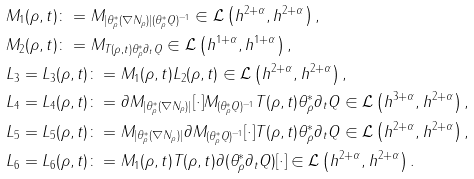Convert formula to latex. <formula><loc_0><loc_0><loc_500><loc_500>& M _ { 1 } ( \rho , t ) \colon = M _ { | \theta _ { \rho } ^ { \ast } ( \nabla N _ { \rho } ) | ( \theta _ { \rho } ^ { \ast } Q ) ^ { - 1 } } \in \mathcal { L } \left ( h ^ { 2 + \alpha } , h ^ { 2 + \alpha } \right ) , \\ & M _ { 2 } ( \rho , t ) \colon = M _ { T ( \rho , t ) \theta _ { \rho } ^ { \ast } \partial _ { t } Q } \in \mathcal { L } \left ( h ^ { 1 + \alpha } , h ^ { 1 + \alpha } \right ) , \\ & L _ { 3 } = L _ { 3 } ( \rho , t ) \colon = M _ { 1 } ( \rho , t ) L _ { 2 } ( \rho , t ) \in \mathcal { L } \left ( h ^ { 2 + \alpha } , h ^ { 2 + \alpha } \right ) , \\ & L _ { 4 } = L _ { 4 } ( \rho , t ) \colon = \partial M _ { | \theta _ { \rho } ^ { \ast } ( \nabla N _ { \rho } ) | } [ \cdot ] M _ { ( \theta _ { \rho } ^ { \ast } Q ) ^ { - 1 } } T ( \rho , t ) \theta _ { \rho } ^ { \ast } \partial _ { t } Q \in \mathcal { L } \left ( h ^ { 3 + \alpha } , h ^ { 2 + \alpha } \right ) , \\ & L _ { 5 } = L _ { 5 } ( \rho , t ) \colon = M _ { | \theta _ { \rho } ^ { \ast } ( \nabla N _ { \rho } ) | } \partial M _ { ( \theta _ { \rho } ^ { \ast } Q ) ^ { - 1 } } [ \cdot ] T ( \rho , t ) \theta _ { \rho } ^ { \ast } \partial _ { t } Q \in \mathcal { L } \left ( h ^ { 2 + \alpha } , h ^ { 2 + \alpha } \right ) , \\ & L _ { 6 } = L _ { 6 } ( \rho , t ) \colon = M _ { 1 } ( \rho , t ) T ( \rho , t ) \partial ( \theta _ { \rho } ^ { \ast } \partial _ { t } Q ) [ \cdot ] \in \mathcal { L } \left ( h ^ { 2 + \alpha } , h ^ { 2 + \alpha } \right ) .</formula> 